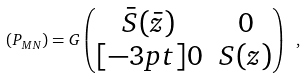<formula> <loc_0><loc_0><loc_500><loc_500>( P _ { M N } ) = G \left ( \begin{matrix} \bar { S } ( \bar { z } ) & 0 \\ [ - 3 p t ] 0 & S ( z ) \end{matrix} \right ) \ ,</formula> 